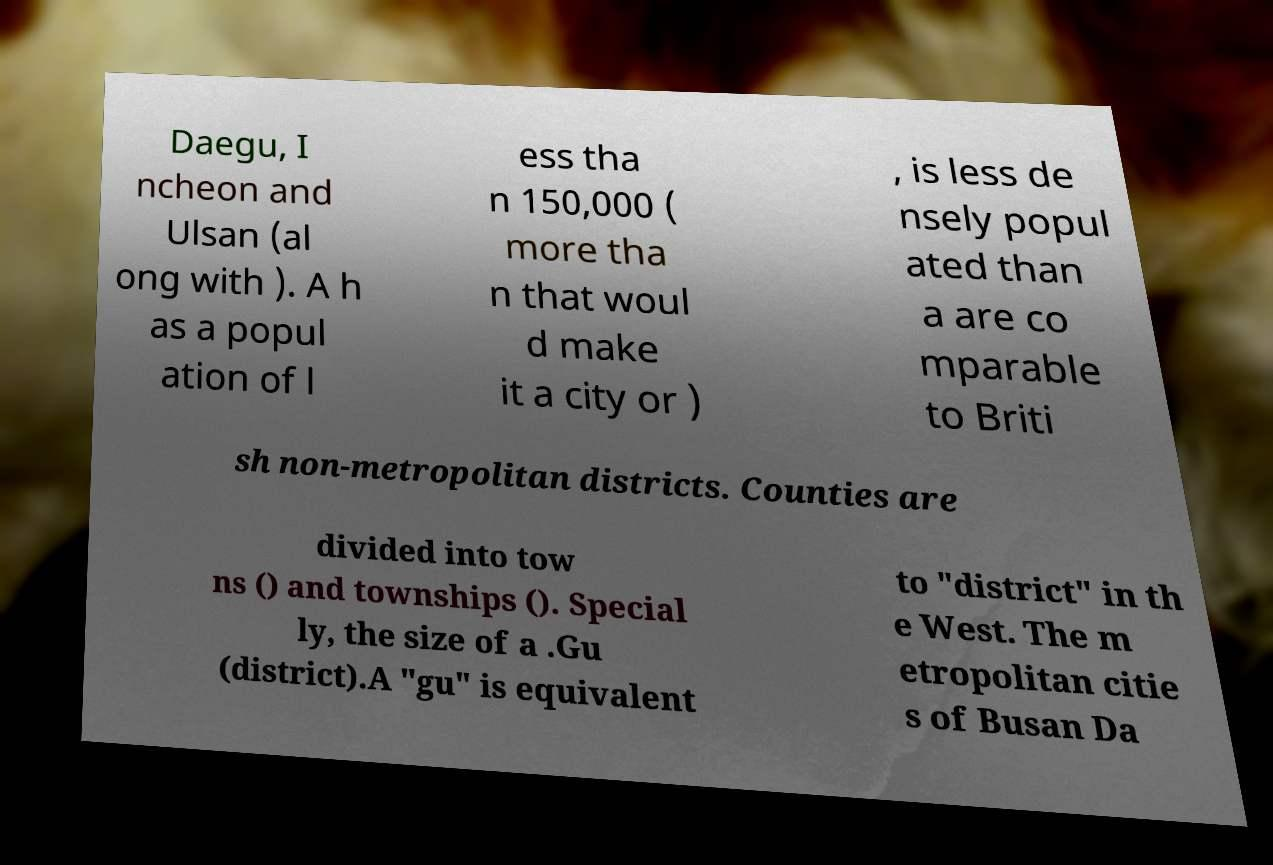Please identify and transcribe the text found in this image. Daegu, I ncheon and Ulsan (al ong with ). A h as a popul ation of l ess tha n 150,000 ( more tha n that woul d make it a city or ) , is less de nsely popul ated than a are co mparable to Briti sh non-metropolitan districts. Counties are divided into tow ns () and townships (). Special ly, the size of a .Gu (district).A "gu" is equivalent to "district" in th e West. The m etropolitan citie s of Busan Da 